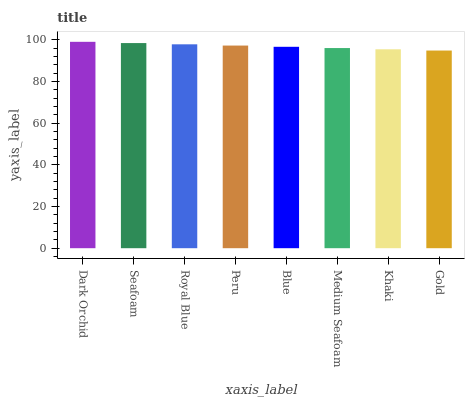Is Gold the minimum?
Answer yes or no. Yes. Is Dark Orchid the maximum?
Answer yes or no. Yes. Is Seafoam the minimum?
Answer yes or no. No. Is Seafoam the maximum?
Answer yes or no. No. Is Dark Orchid greater than Seafoam?
Answer yes or no. Yes. Is Seafoam less than Dark Orchid?
Answer yes or no. Yes. Is Seafoam greater than Dark Orchid?
Answer yes or no. No. Is Dark Orchid less than Seafoam?
Answer yes or no. No. Is Peru the high median?
Answer yes or no. Yes. Is Blue the low median?
Answer yes or no. Yes. Is Seafoam the high median?
Answer yes or no. No. Is Seafoam the low median?
Answer yes or no. No. 